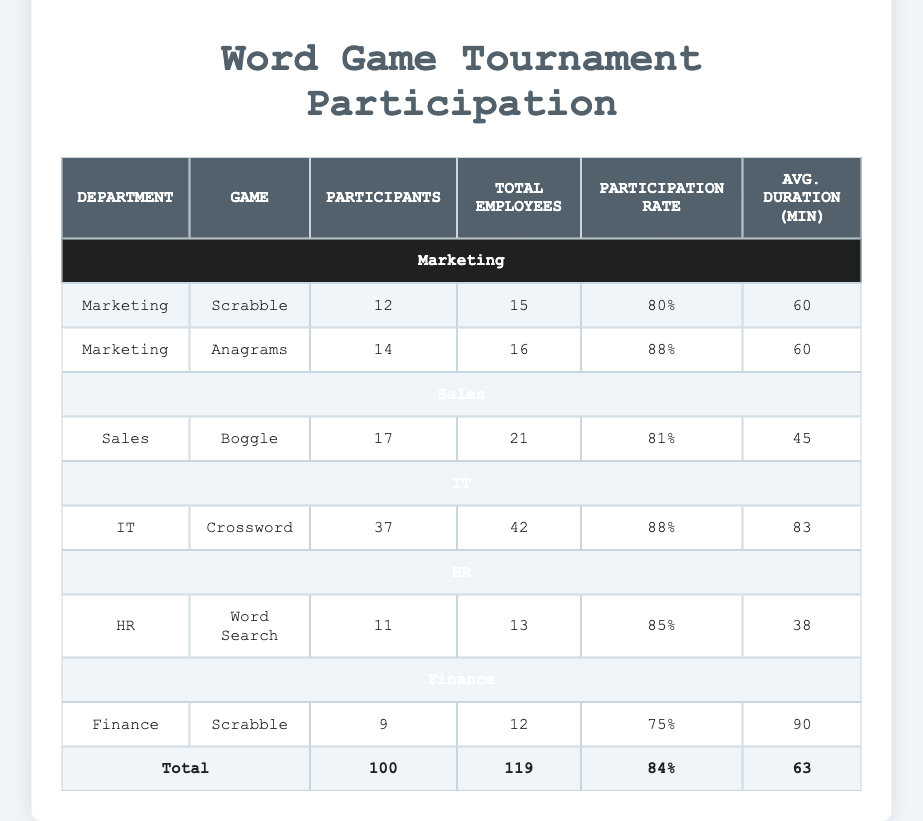What is the participation rate for the Marketing department in the Scrabble game? The participation rate is calculated as the number of participants divided by the total number of employees. For Marketing in Scrabble, there were 12 participants out of 15 employees. Thus, the participation rate is (12/15) * 100% = 80%.
Answer: 80% Which game had the highest number of participants? To find the game with the highest participation, we can compare the participants for each game recorded in the table. The highest number is 19 participants for the Crossword game played by the IT department.
Answer: Crossword Is the average duration of games in the HR department greater than 40 minutes? We look at the games played by HR. There are two games: Word Search with a duration of 45 minutes and another game with a duration of 30 minutes. To find the average, we calculate (45 + 30)/2 = 37.5 minutes, which is less than 40.
Answer: No What is the total number of participants across all games? We sum the number of participants from all entries: 12 + 8 + 18 + 5 + 9 + 14 + 9 + 19 + 6 = 100. This gives us the total number of participants across all games.
Answer: 100 Was the participation rate in the Sales department below 80% for both games they played? We look at the participation rates for Sales in both games: Boggle with 8 participants out of 10 employees (80%) and then Boggle again with 9 participants out of 11 employees, which is approximately 81.8%. Since both rates are equal to or above 80%, the answer is no.
Answer: No Which department had the lowest average participation rate? To calculate the average participation rate for each department, we find the sum of participants and divide by the sum of total employees. The average participation rates are: Marketing (84%), Sales (81%), IT (88%), HR (85%), and Finance (75%). The lowest is Finance with a rate of 75%.
Answer: Finance How many total employees participated in the word game tournaments? We refer to the table to find the total number of employees. To do this, we add the numbers from the total employees column: 15 + 10 + 20 + 6 + 12 + 16 + 11 + 22 + 7 = 119.
Answer: 119 Did all games played by the IT department have a participation rate above 85%? The IT department played two games: Crossword with 18 participants from 20 employees (90%) and a second Crossword with 19 participants from 22 employees (86.4%). Since both rates exceed 85%, the answer is yes.
Answer: Yes 